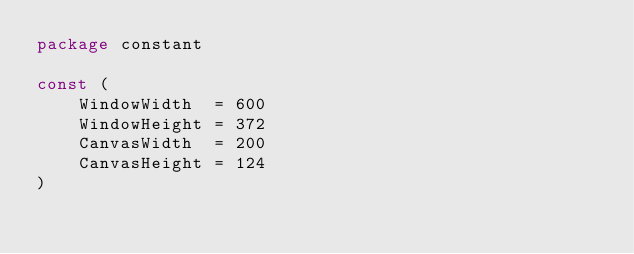Convert code to text. <code><loc_0><loc_0><loc_500><loc_500><_Go_>package constant

const (
	WindowWidth  = 600
	WindowHeight = 372
	CanvasWidth  = 200
	CanvasHeight = 124
)
</code> 